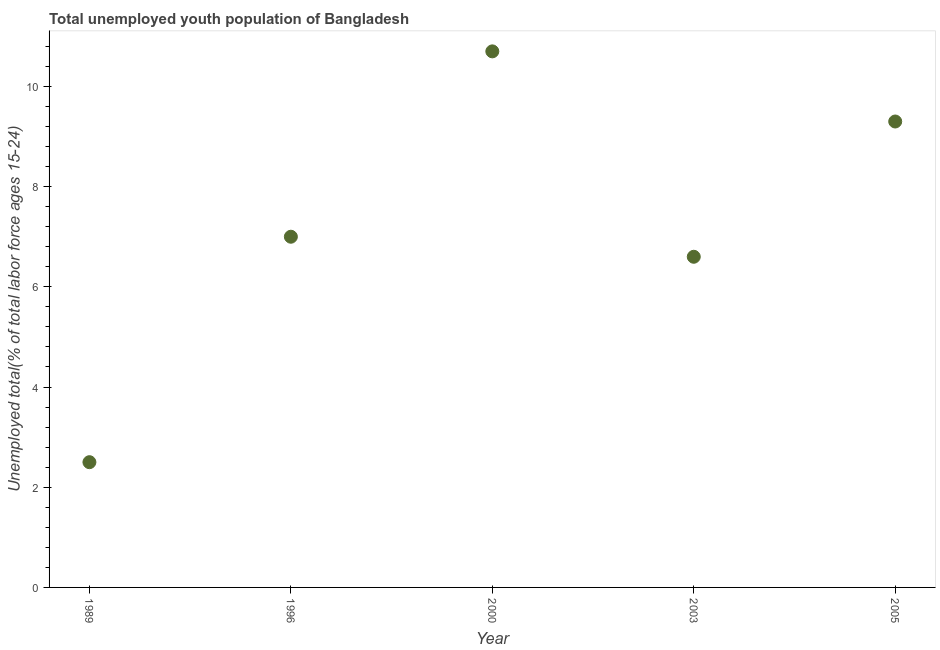What is the unemployed youth in 2003?
Your response must be concise. 6.6. Across all years, what is the maximum unemployed youth?
Your answer should be compact. 10.7. In which year was the unemployed youth minimum?
Your answer should be compact. 1989. What is the sum of the unemployed youth?
Provide a short and direct response. 36.1. What is the difference between the unemployed youth in 2003 and 2005?
Offer a very short reply. -2.7. What is the average unemployed youth per year?
Your response must be concise. 7.22. What is the median unemployed youth?
Give a very brief answer. 7. In how many years, is the unemployed youth greater than 5.6 %?
Your answer should be compact. 4. Do a majority of the years between 1996 and 2003 (inclusive) have unemployed youth greater than 3.6 %?
Keep it short and to the point. Yes. What is the ratio of the unemployed youth in 1989 to that in 2003?
Offer a terse response. 0.38. Is the difference between the unemployed youth in 2000 and 2005 greater than the difference between any two years?
Provide a succinct answer. No. What is the difference between the highest and the second highest unemployed youth?
Ensure brevity in your answer.  1.4. What is the difference between the highest and the lowest unemployed youth?
Provide a short and direct response. 8.2. In how many years, is the unemployed youth greater than the average unemployed youth taken over all years?
Offer a very short reply. 2. Does the unemployed youth monotonically increase over the years?
Make the answer very short. No. Does the graph contain grids?
Give a very brief answer. No. What is the title of the graph?
Your response must be concise. Total unemployed youth population of Bangladesh. What is the label or title of the Y-axis?
Keep it short and to the point. Unemployed total(% of total labor force ages 15-24). What is the Unemployed total(% of total labor force ages 15-24) in 1996?
Provide a short and direct response. 7. What is the Unemployed total(% of total labor force ages 15-24) in 2000?
Your answer should be very brief. 10.7. What is the Unemployed total(% of total labor force ages 15-24) in 2003?
Make the answer very short. 6.6. What is the Unemployed total(% of total labor force ages 15-24) in 2005?
Offer a very short reply. 9.3. What is the difference between the Unemployed total(% of total labor force ages 15-24) in 1989 and 2000?
Your answer should be very brief. -8.2. What is the difference between the Unemployed total(% of total labor force ages 15-24) in 1996 and 2000?
Ensure brevity in your answer.  -3.7. What is the difference between the Unemployed total(% of total labor force ages 15-24) in 1996 and 2003?
Offer a very short reply. 0.4. What is the difference between the Unemployed total(% of total labor force ages 15-24) in 1996 and 2005?
Provide a short and direct response. -2.3. What is the difference between the Unemployed total(% of total labor force ages 15-24) in 2003 and 2005?
Give a very brief answer. -2.7. What is the ratio of the Unemployed total(% of total labor force ages 15-24) in 1989 to that in 1996?
Provide a short and direct response. 0.36. What is the ratio of the Unemployed total(% of total labor force ages 15-24) in 1989 to that in 2000?
Give a very brief answer. 0.23. What is the ratio of the Unemployed total(% of total labor force ages 15-24) in 1989 to that in 2003?
Your response must be concise. 0.38. What is the ratio of the Unemployed total(% of total labor force ages 15-24) in 1989 to that in 2005?
Your response must be concise. 0.27. What is the ratio of the Unemployed total(% of total labor force ages 15-24) in 1996 to that in 2000?
Offer a terse response. 0.65. What is the ratio of the Unemployed total(% of total labor force ages 15-24) in 1996 to that in 2003?
Provide a succinct answer. 1.06. What is the ratio of the Unemployed total(% of total labor force ages 15-24) in 1996 to that in 2005?
Your answer should be compact. 0.75. What is the ratio of the Unemployed total(% of total labor force ages 15-24) in 2000 to that in 2003?
Ensure brevity in your answer.  1.62. What is the ratio of the Unemployed total(% of total labor force ages 15-24) in 2000 to that in 2005?
Provide a short and direct response. 1.15. What is the ratio of the Unemployed total(% of total labor force ages 15-24) in 2003 to that in 2005?
Give a very brief answer. 0.71. 